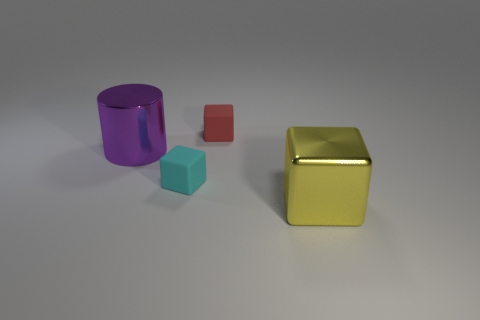Add 1 spheres. How many objects exist? 5 Subtract all cylinders. How many objects are left? 3 Add 4 yellow metal blocks. How many yellow metal blocks are left? 5 Add 3 yellow metallic objects. How many yellow metallic objects exist? 4 Subtract 0 red cylinders. How many objects are left? 4 Subtract all small rubber cubes. Subtract all small objects. How many objects are left? 0 